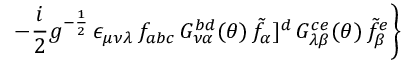Convert formula to latex. <formula><loc_0><loc_0><loc_500><loc_500>- \frac { i } { 2 } g ^ { - \frac { 1 } { 2 } } \, \epsilon _ { \mu \nu \lambda } \, f _ { a b c } \, G _ { \nu \alpha } ^ { b d } ( \theta ) \, { \tilde { f } } _ { \alpha } ] ^ { d } \, G _ { \lambda \beta } ^ { c e } ( \theta ) \, { \tilde { f } } _ { \beta } ^ { e } \right \}</formula> 